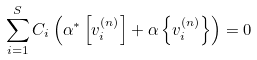Convert formula to latex. <formula><loc_0><loc_0><loc_500><loc_500>\sum _ { i = 1 } ^ { S } C _ { i } \left ( \alpha ^ { * } \left [ v _ { i } ^ { ( n ) } \right ] + \alpha \left \{ v _ { i } ^ { ( n ) } \right \} \right ) = 0</formula> 